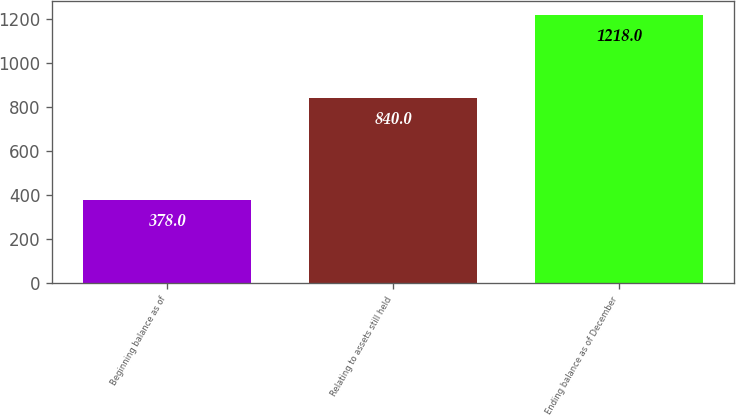Convert chart to OTSL. <chart><loc_0><loc_0><loc_500><loc_500><bar_chart><fcel>Beginning balance as of<fcel>Relating to assets still held<fcel>Ending balance as of December<nl><fcel>378<fcel>840<fcel>1218<nl></chart> 